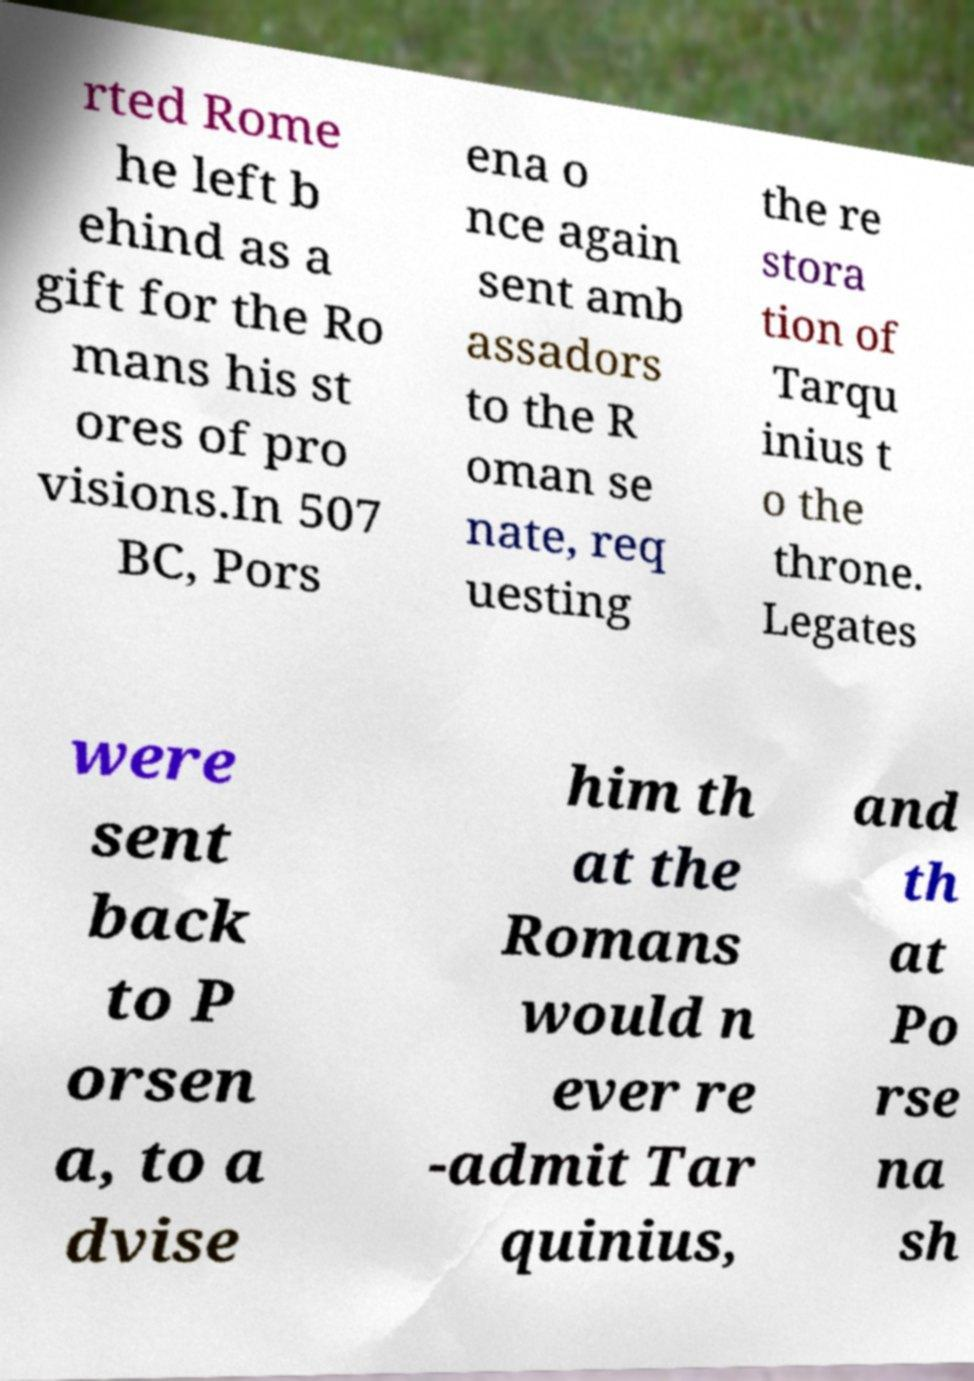Could you extract and type out the text from this image? rted Rome he left b ehind as a gift for the Ro mans his st ores of pro visions.In 507 BC, Pors ena o nce again sent amb assadors to the R oman se nate, req uesting the re stora tion of Tarqu inius t o the throne. Legates were sent back to P orsen a, to a dvise him th at the Romans would n ever re -admit Tar quinius, and th at Po rse na sh 